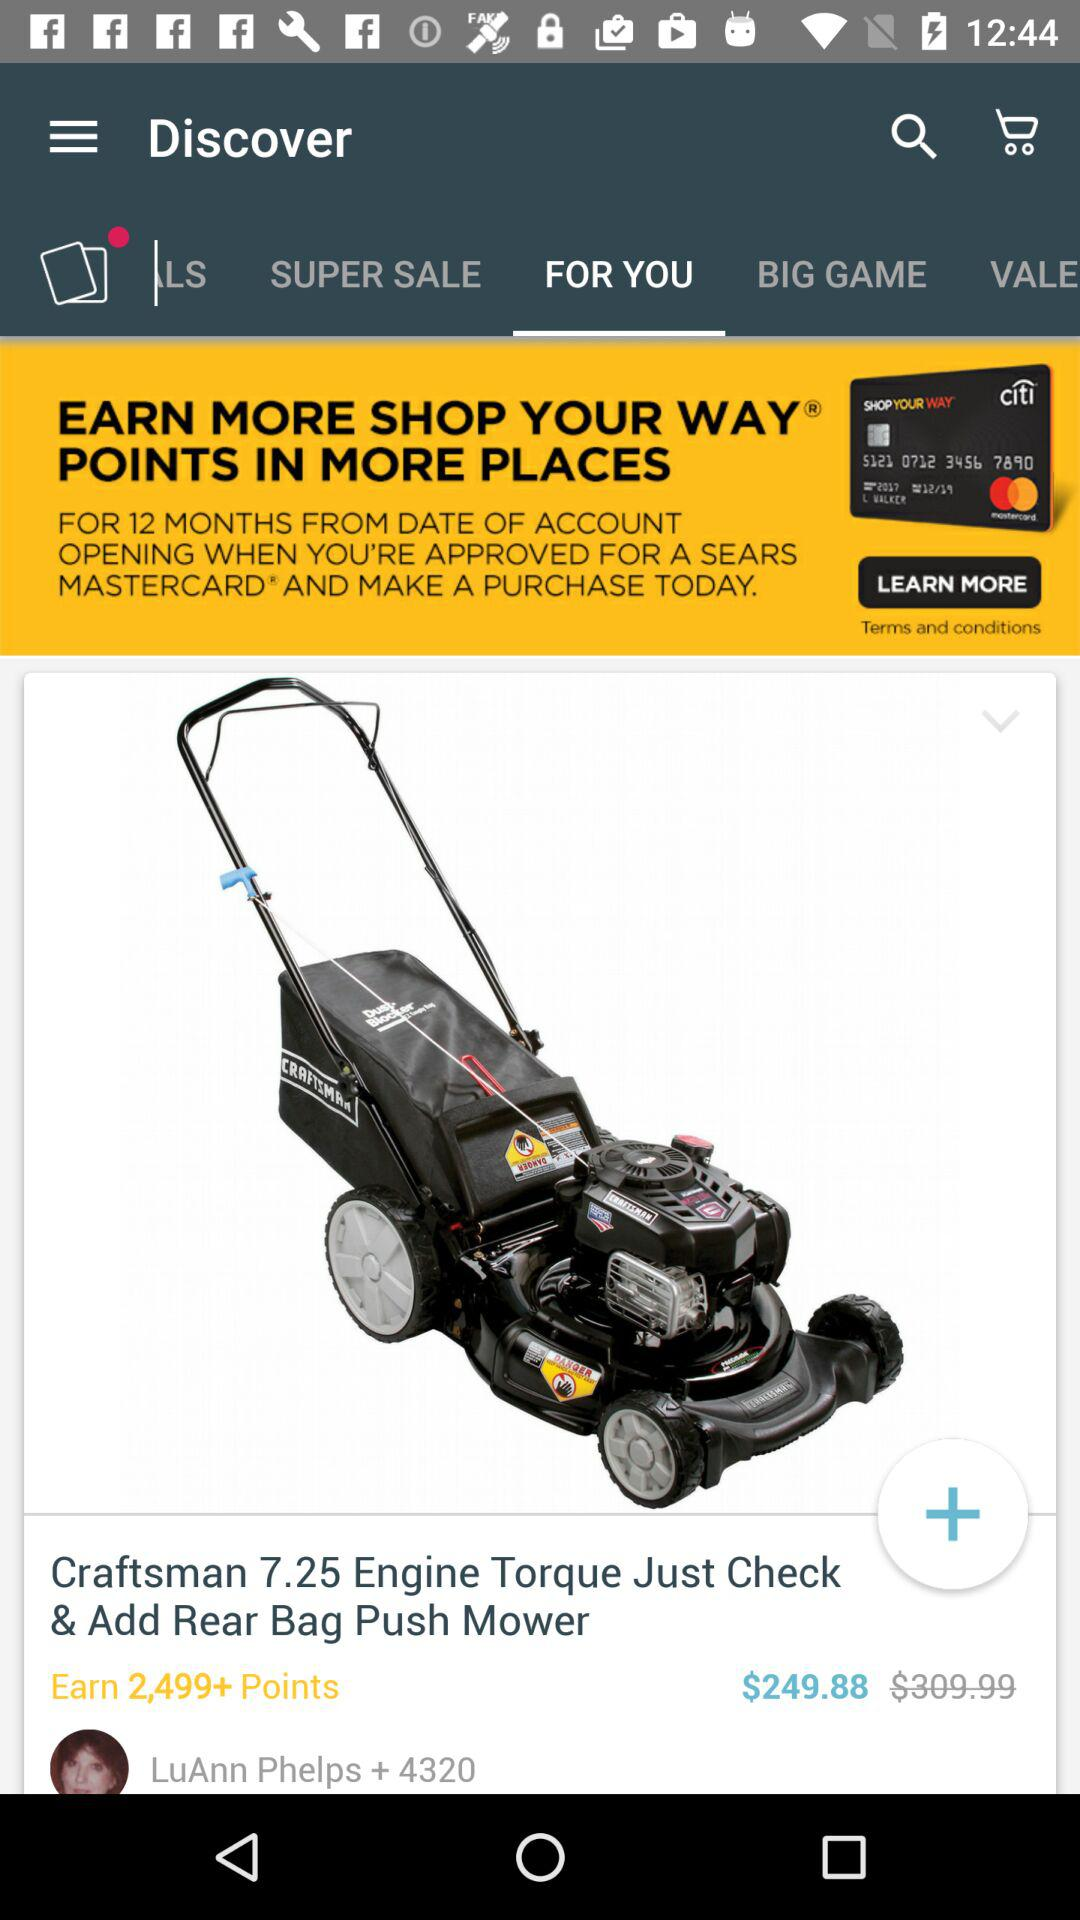What tab is selected? The selected tab is "FOR YOU". 